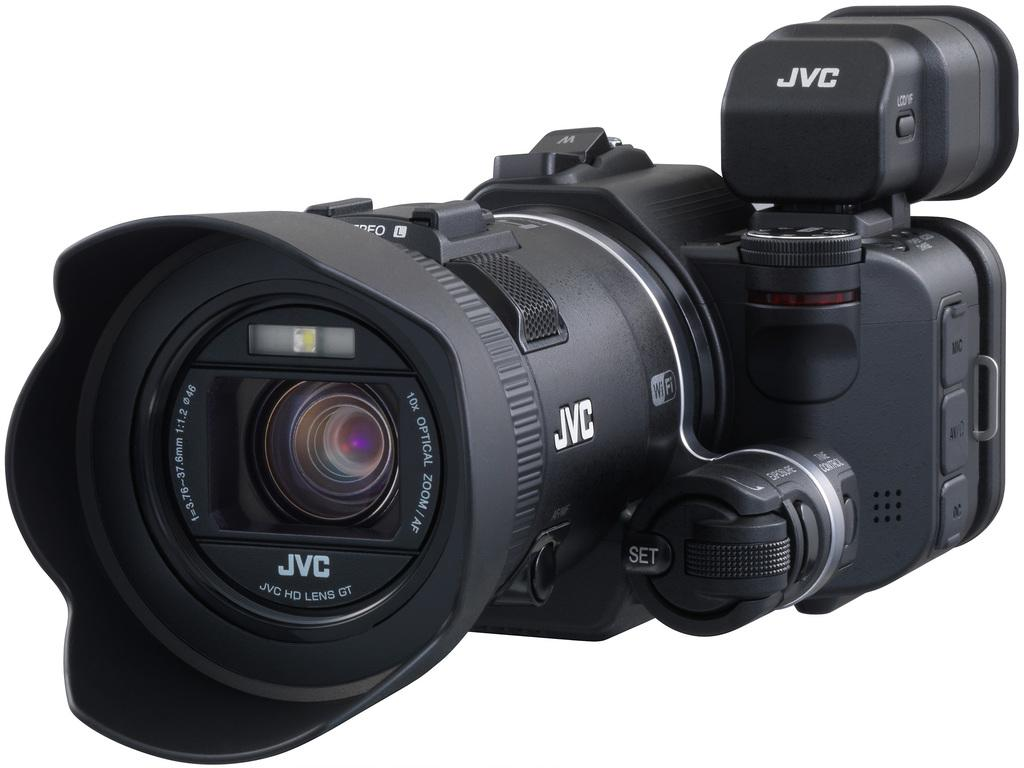What object is the main subject of the image? There is a camera in the image. Can you describe any additional details about the camera? Something is written on the camera. What color is the background of the image? The background of the image is white. What type of apparel is being worn by the camera in the image? There is no apparel present in the image, as the subject is a camera. What effect does the camera have on the background of the image? The camera does not have any effect on the background of the image, as it is a static object in the photograph. 